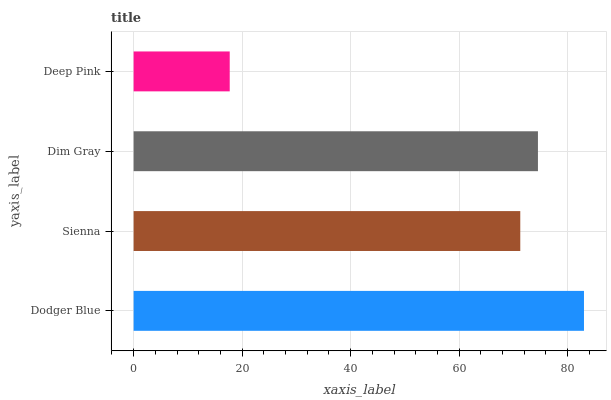Is Deep Pink the minimum?
Answer yes or no. Yes. Is Dodger Blue the maximum?
Answer yes or no. Yes. Is Sienna the minimum?
Answer yes or no. No. Is Sienna the maximum?
Answer yes or no. No. Is Dodger Blue greater than Sienna?
Answer yes or no. Yes. Is Sienna less than Dodger Blue?
Answer yes or no. Yes. Is Sienna greater than Dodger Blue?
Answer yes or no. No. Is Dodger Blue less than Sienna?
Answer yes or no. No. Is Dim Gray the high median?
Answer yes or no. Yes. Is Sienna the low median?
Answer yes or no. Yes. Is Deep Pink the high median?
Answer yes or no. No. Is Dim Gray the low median?
Answer yes or no. No. 